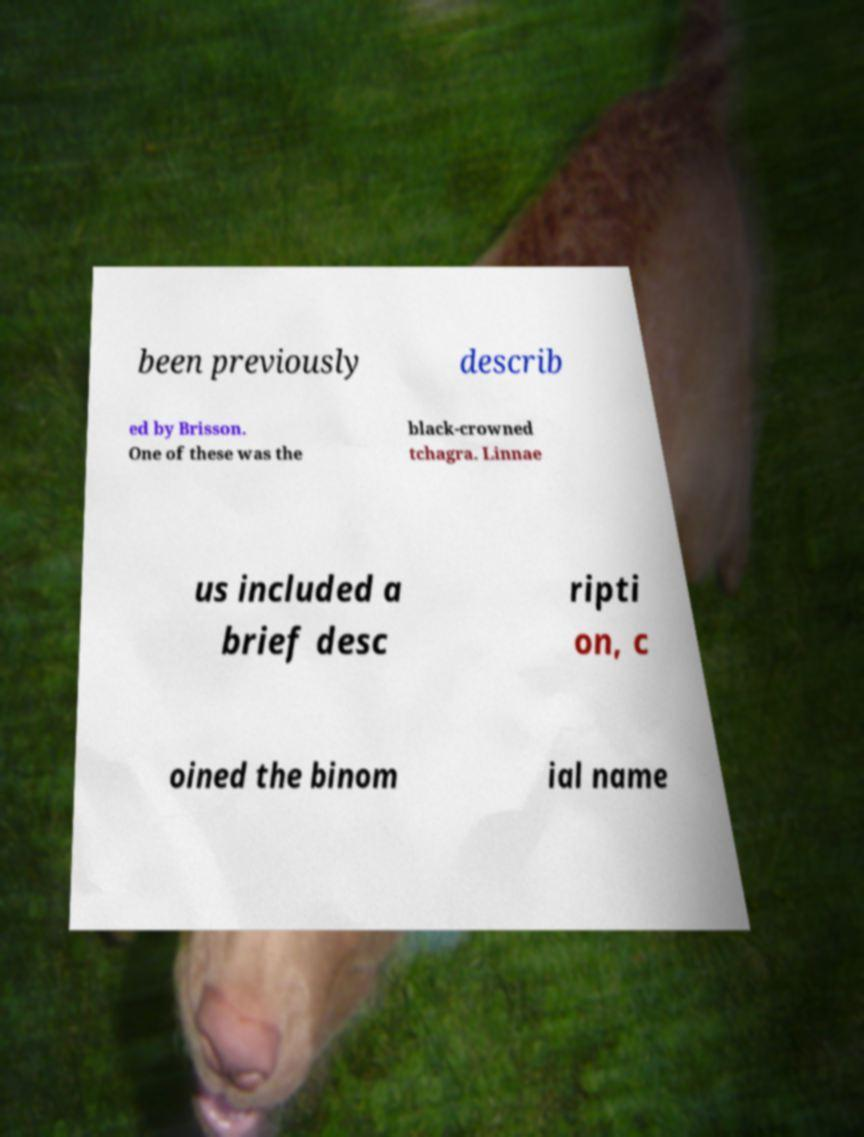Could you assist in decoding the text presented in this image and type it out clearly? been previously describ ed by Brisson. One of these was the black-crowned tchagra. Linnae us included a brief desc ripti on, c oined the binom ial name 